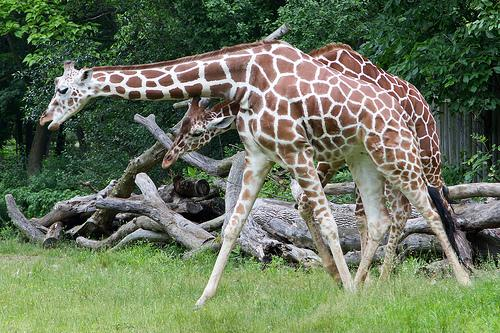Briefly mention the plants in the image and their basic characteristics. There are tall green trees, thick dark green bushes, and light green grass in the field where the giraffes are situated. Describe the trees and tree parts seen in the image. There are tall green trees, tree stumps and branches, and logs lying on the ground near the giraffes in the field. Mention the primary objects and their colors in the picture. Two giraffes with brown and white fur, tall green grass, green leaves, and a grey wooden fence are visible in the image. What action is one of the giraffes performing? One of the giraffes has its mouth open, possibly eating or communicating with the other giraffe. Describe the unique features of the giraffes' body and fur. The giraffes exhibit long skinny legs, a long neck with brown spots, black hair on the tip of the tail, and a mix of brown and white fur. Describe the main focus of the image and its surroundings. The image features a pair of giraffes with brown spots, standing on a field of green grass with logs, trees, and a wooden fence nearby. Mention a specific interaction between the two giraffes. One giraffe's head is positioned under the other giraffe's neck, possibly indicating a close and affectionate interaction. Write a concise observation about the giraffes' position in relation to other objects. The giraffes stand next to tall green trees and logs, with their feet partially obscured by the tall grass. State the number of legs visible and any specifics about them. Eight long giraffe legs are showing, with each leg being long, skinny, and covered with brown and white fur. List the various elements found in the environment of the image. Grass, tall trees, green leaves, tree logs, wooden fence, giraffes, giraffe legs, and giraffe tail. 